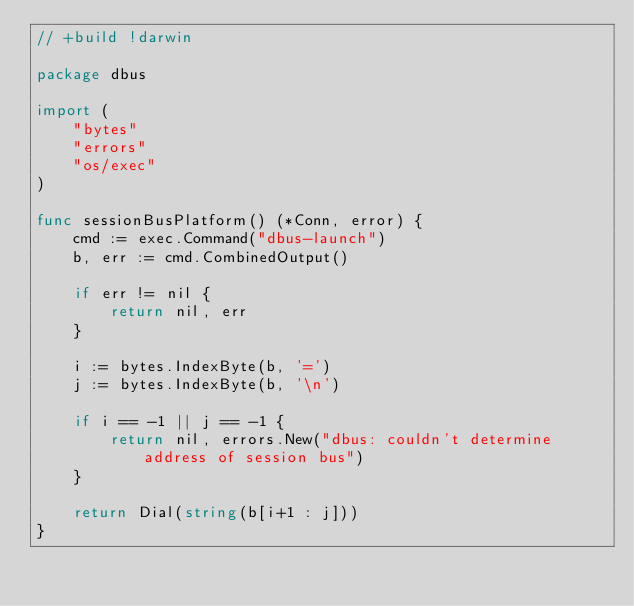Convert code to text. <code><loc_0><loc_0><loc_500><loc_500><_Go_>// +build !darwin

package dbus

import (
	"bytes"
	"errors"
	"os/exec"
)

func sessionBusPlatform() (*Conn, error) {
	cmd := exec.Command("dbus-launch")
	b, err := cmd.CombinedOutput()

	if err != nil {
		return nil, err
	}

	i := bytes.IndexByte(b, '=')
	j := bytes.IndexByte(b, '\n')

	if i == -1 || j == -1 {
		return nil, errors.New("dbus: couldn't determine address of session bus")
	}

	return Dial(string(b[i+1 : j]))
}
</code> 